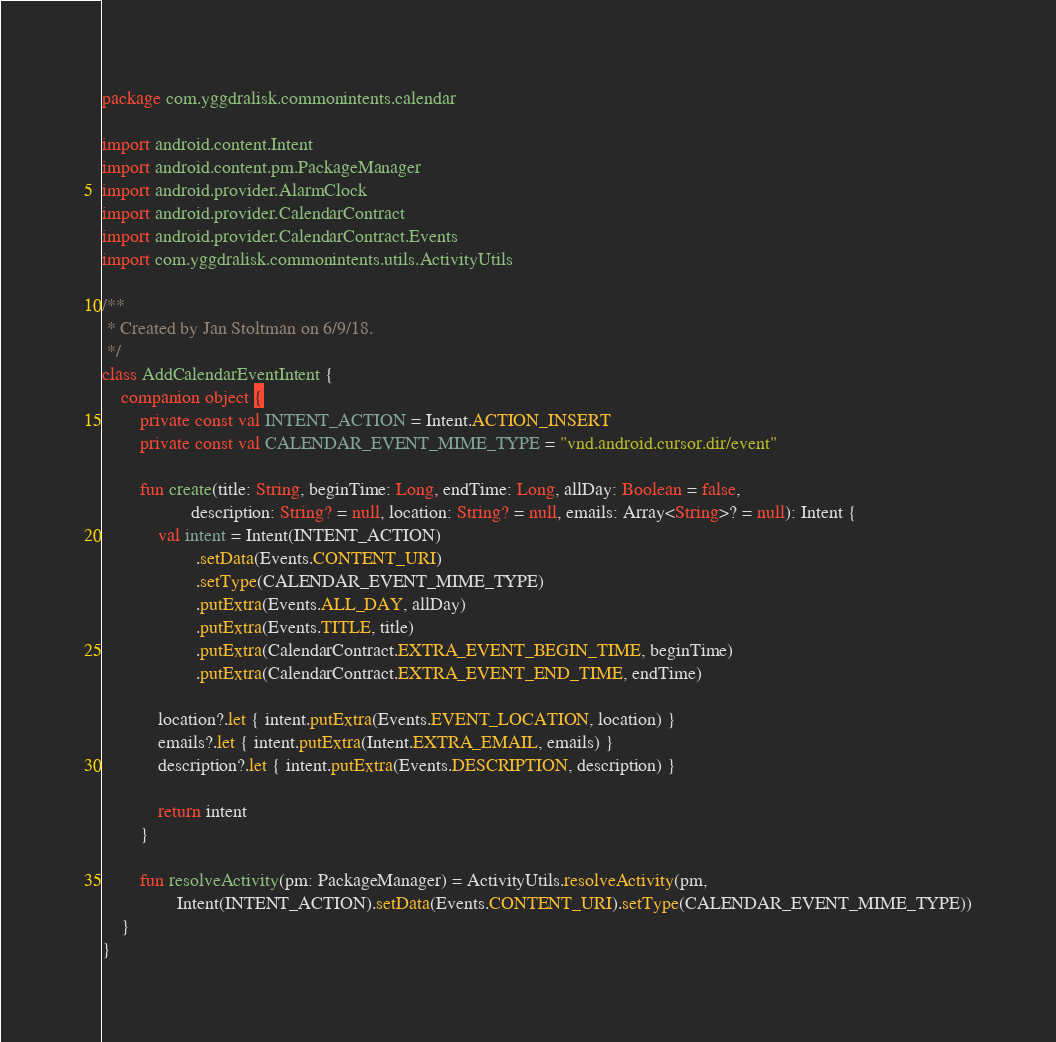Convert code to text. <code><loc_0><loc_0><loc_500><loc_500><_Kotlin_>package com.yggdralisk.commonintents.calendar

import android.content.Intent
import android.content.pm.PackageManager
import android.provider.AlarmClock
import android.provider.CalendarContract
import android.provider.CalendarContract.Events
import com.yggdralisk.commonintents.utils.ActivityUtils

/**
 * Created by Jan Stoltman on 6/9/18.
 */
class AddCalendarEventIntent {
    companion object {
        private const val INTENT_ACTION = Intent.ACTION_INSERT
        private const val CALENDAR_EVENT_MIME_TYPE = "vnd.android.cursor.dir/event"

        fun create(title: String, beginTime: Long, endTime: Long, allDay: Boolean = false,
                   description: String? = null, location: String? = null, emails: Array<String>? = null): Intent {
            val intent = Intent(INTENT_ACTION)
                    .setData(Events.CONTENT_URI)
                    .setType(CALENDAR_EVENT_MIME_TYPE)
                    .putExtra(Events.ALL_DAY, allDay)
                    .putExtra(Events.TITLE, title)
                    .putExtra(CalendarContract.EXTRA_EVENT_BEGIN_TIME, beginTime)
                    .putExtra(CalendarContract.EXTRA_EVENT_END_TIME, endTime)

            location?.let { intent.putExtra(Events.EVENT_LOCATION, location) }
            emails?.let { intent.putExtra(Intent.EXTRA_EMAIL, emails) }
            description?.let { intent.putExtra(Events.DESCRIPTION, description) }

            return intent
        }

        fun resolveActivity(pm: PackageManager) = ActivityUtils.resolveActivity(pm,
                Intent(INTENT_ACTION).setData(Events.CONTENT_URI).setType(CALENDAR_EVENT_MIME_TYPE))
    }
}</code> 